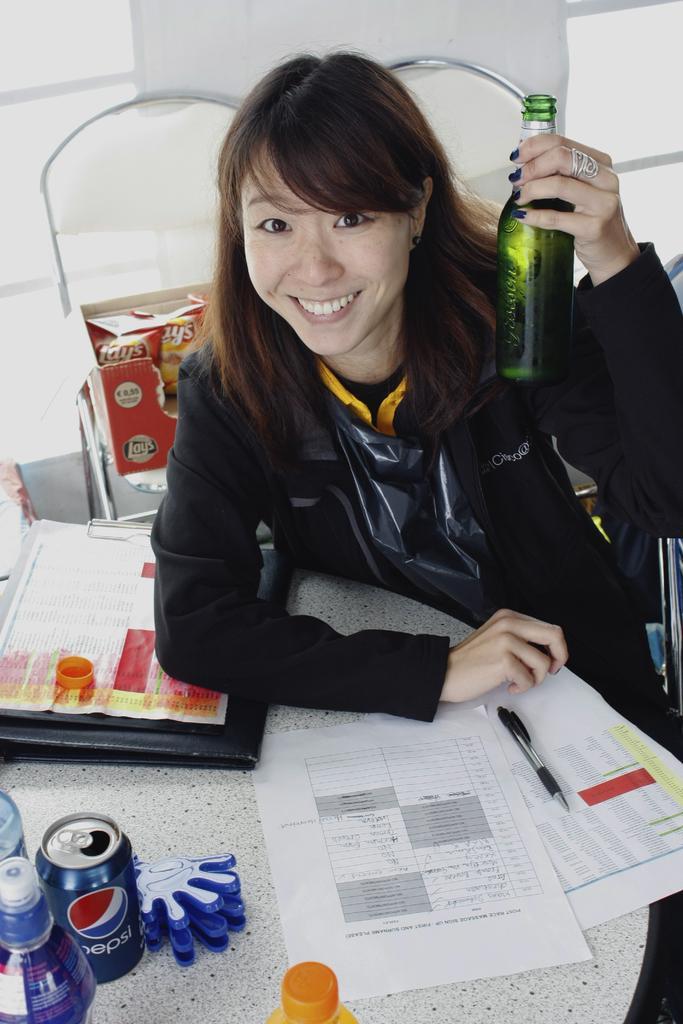Please provide a concise description of this image. In this image I see a woman who is sitting and she is holding a bottle and I can also see she is smiling. In front of here there are few papers, cans and bottles. 